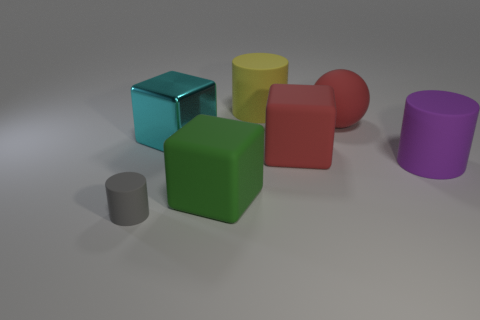Subtract all tiny matte cylinders. How many cylinders are left? 2 Add 2 large blue rubber objects. How many objects exist? 9 Subtract all gray cylinders. How many cylinders are left? 2 Subtract all cylinders. How many objects are left? 4 Subtract 3 blocks. How many blocks are left? 0 Add 5 yellow rubber things. How many yellow rubber things exist? 6 Subtract 0 red cylinders. How many objects are left? 7 Subtract all cyan spheres. Subtract all cyan cubes. How many spheres are left? 1 Subtract all big red rubber balls. Subtract all rubber cylinders. How many objects are left? 3 Add 7 green objects. How many green objects are left? 8 